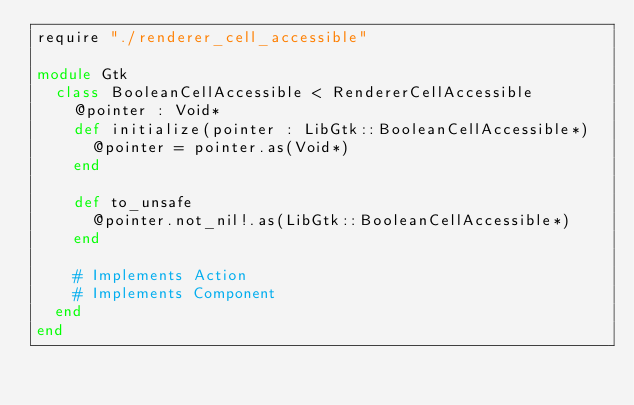<code> <loc_0><loc_0><loc_500><loc_500><_Crystal_>require "./renderer_cell_accessible"

module Gtk
  class BooleanCellAccessible < RendererCellAccessible
    @pointer : Void*
    def initialize(pointer : LibGtk::BooleanCellAccessible*)
      @pointer = pointer.as(Void*)
    end

    def to_unsafe
      @pointer.not_nil!.as(LibGtk::BooleanCellAccessible*)
    end

    # Implements Action
    # Implements Component
  end
end

</code> 